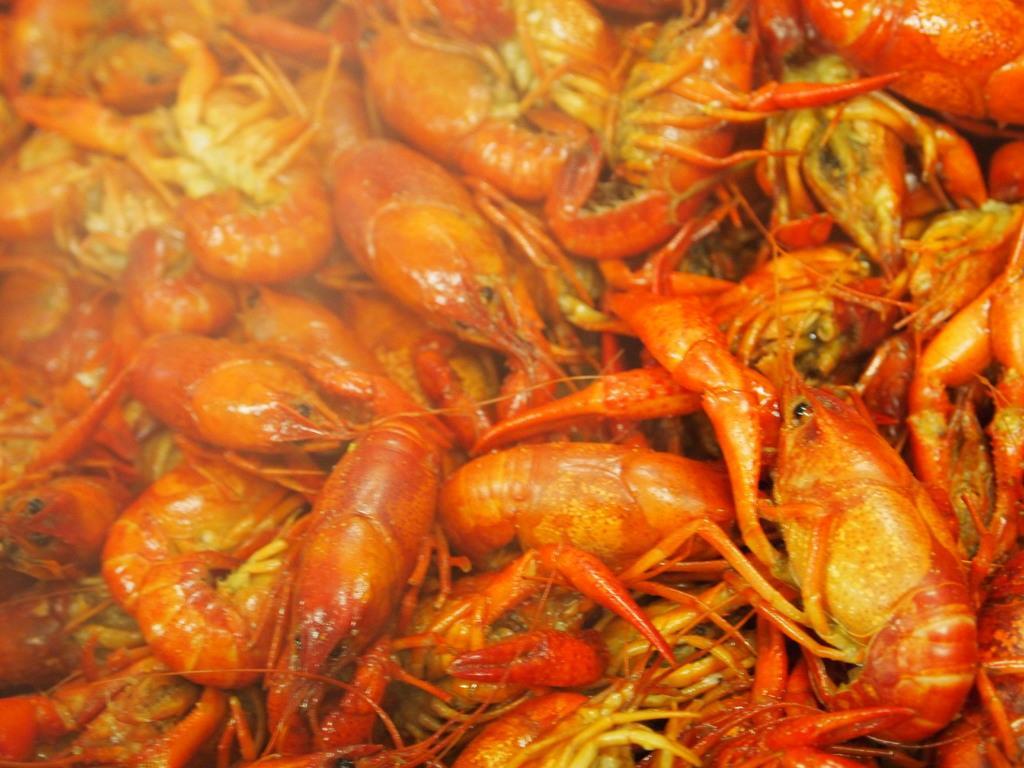Could you give a brief overview of what you see in this image? In this image we can see the prawns. 